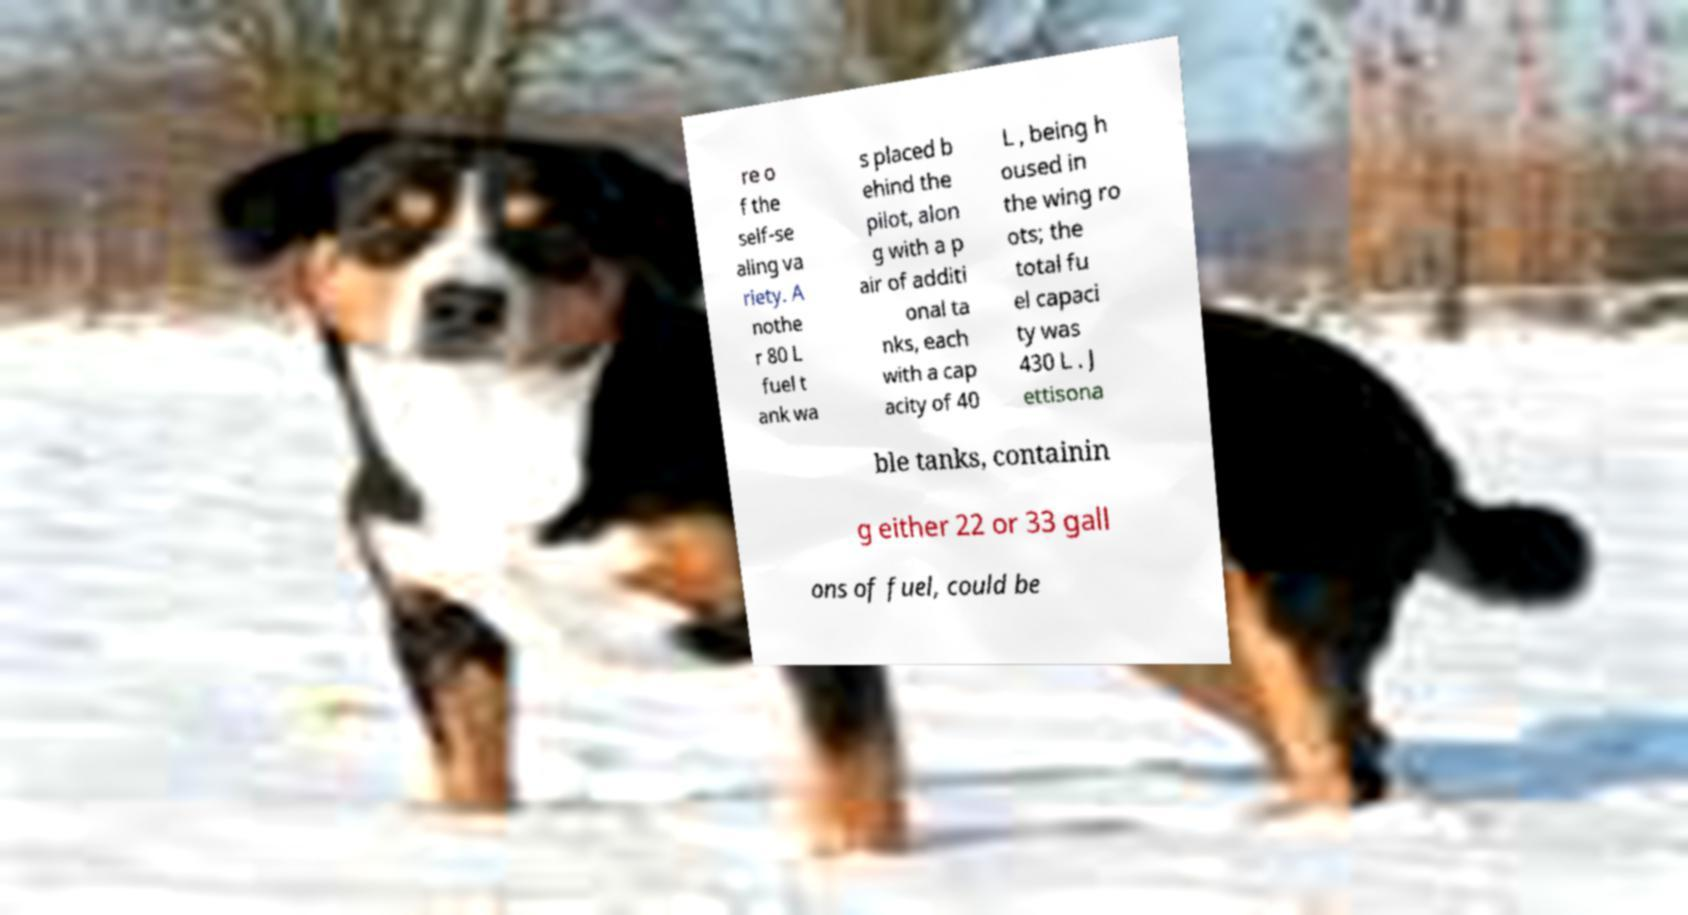For documentation purposes, I need the text within this image transcribed. Could you provide that? re o f the self-se aling va riety. A nothe r 80 L fuel t ank wa s placed b ehind the pilot, alon g with a p air of additi onal ta nks, each with a cap acity of 40 L , being h oused in the wing ro ots; the total fu el capaci ty was 430 L . J ettisona ble tanks, containin g either 22 or 33 gall ons of fuel, could be 